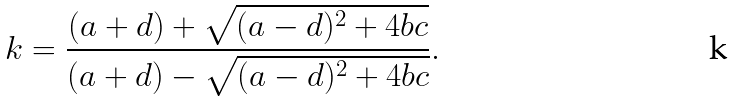Convert formula to latex. <formula><loc_0><loc_0><loc_500><loc_500>k = { \frac { ( a + d ) + { \sqrt { ( a - d ) ^ { 2 } + 4 b c } } } { ( a + d ) - { \sqrt { ( a - d ) ^ { 2 } + 4 b c } } } } .</formula> 